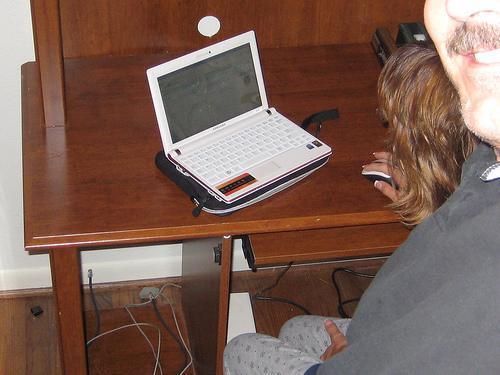How many people are in the picture?
Give a very brief answer. 2. 